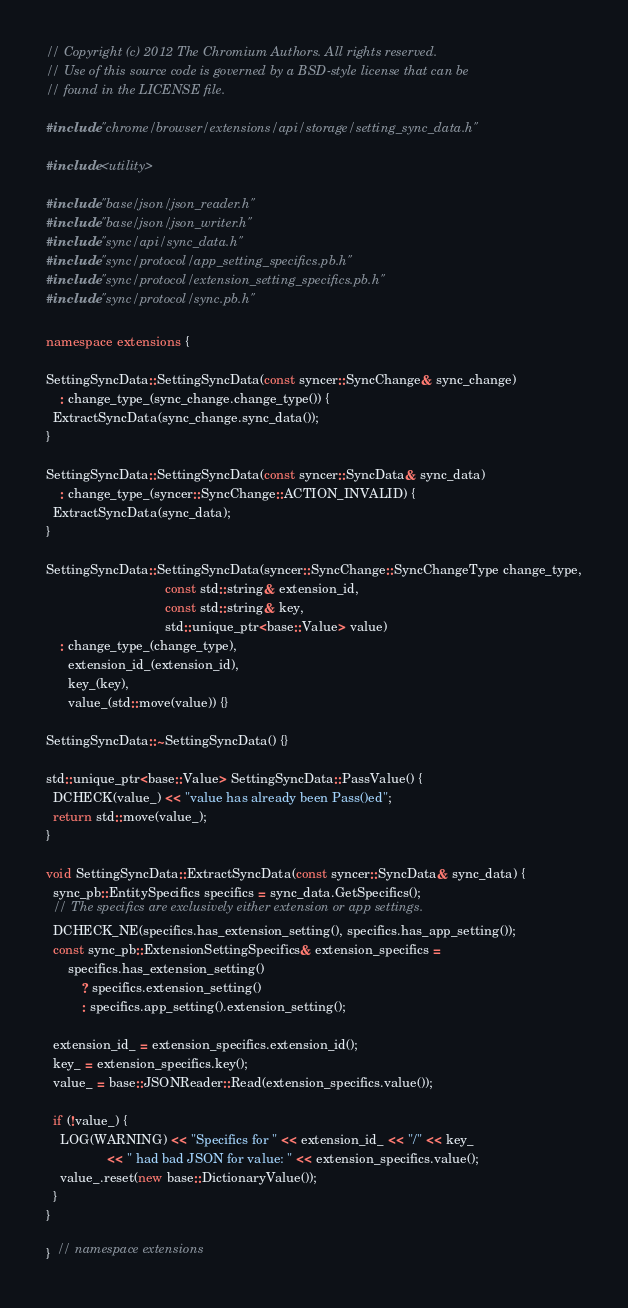Convert code to text. <code><loc_0><loc_0><loc_500><loc_500><_C++_>// Copyright (c) 2012 The Chromium Authors. All rights reserved.
// Use of this source code is governed by a BSD-style license that can be
// found in the LICENSE file.

#include "chrome/browser/extensions/api/storage/setting_sync_data.h"

#include <utility>

#include "base/json/json_reader.h"
#include "base/json/json_writer.h"
#include "sync/api/sync_data.h"
#include "sync/protocol/app_setting_specifics.pb.h"
#include "sync/protocol/extension_setting_specifics.pb.h"
#include "sync/protocol/sync.pb.h"

namespace extensions {

SettingSyncData::SettingSyncData(const syncer::SyncChange& sync_change)
    : change_type_(sync_change.change_type()) {
  ExtractSyncData(sync_change.sync_data());
}

SettingSyncData::SettingSyncData(const syncer::SyncData& sync_data)
    : change_type_(syncer::SyncChange::ACTION_INVALID) {
  ExtractSyncData(sync_data);
}

SettingSyncData::SettingSyncData(syncer::SyncChange::SyncChangeType change_type,
                                 const std::string& extension_id,
                                 const std::string& key,
                                 std::unique_ptr<base::Value> value)
    : change_type_(change_type),
      extension_id_(extension_id),
      key_(key),
      value_(std::move(value)) {}

SettingSyncData::~SettingSyncData() {}

std::unique_ptr<base::Value> SettingSyncData::PassValue() {
  DCHECK(value_) << "value has already been Pass()ed";
  return std::move(value_);
}

void SettingSyncData::ExtractSyncData(const syncer::SyncData& sync_data) {
  sync_pb::EntitySpecifics specifics = sync_data.GetSpecifics();
  // The specifics are exclusively either extension or app settings.
  DCHECK_NE(specifics.has_extension_setting(), specifics.has_app_setting());
  const sync_pb::ExtensionSettingSpecifics& extension_specifics =
      specifics.has_extension_setting()
          ? specifics.extension_setting()
          : specifics.app_setting().extension_setting();

  extension_id_ = extension_specifics.extension_id();
  key_ = extension_specifics.key();
  value_ = base::JSONReader::Read(extension_specifics.value());

  if (!value_) {
    LOG(WARNING) << "Specifics for " << extension_id_ << "/" << key_
                 << " had bad JSON for value: " << extension_specifics.value();
    value_.reset(new base::DictionaryValue());
  }
}

}  // namespace extensions
</code> 